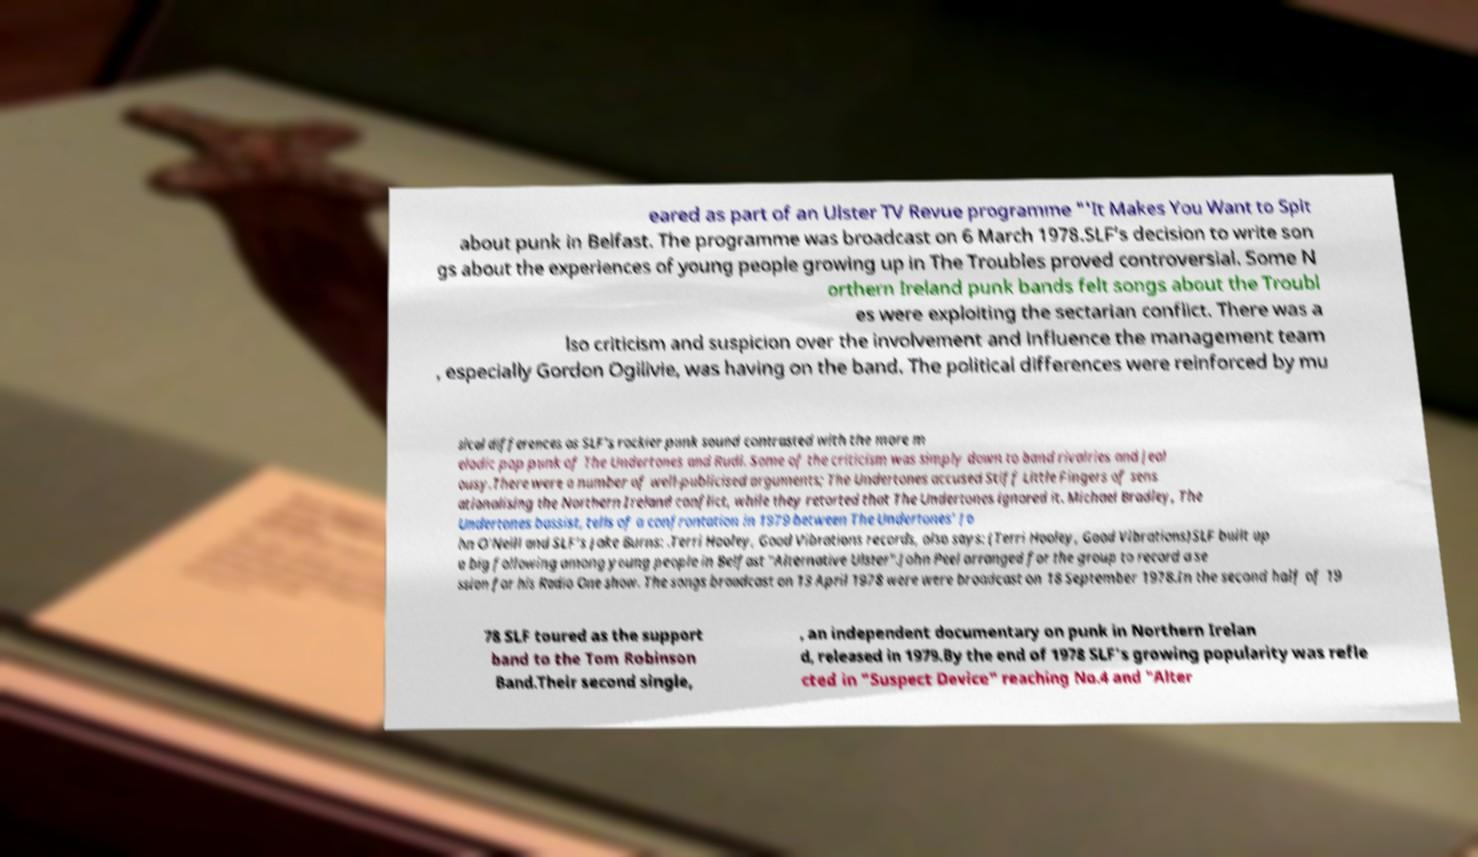Please identify and transcribe the text found in this image. eared as part of an Ulster TV Revue programme "'It Makes You Want to Spit about punk in Belfast. The programme was broadcast on 6 March 1978.SLF’s decision to write son gs about the experiences of young people growing up in The Troubles proved controversial. Some N orthern Ireland punk bands felt songs about the Troubl es were exploiting the sectarian conflict. There was a lso criticism and suspicion over the involvement and influence the management team , especially Gordon Ogilivie, was having on the band. The political differences were reinforced by mu sical differences as SLF’s rockier punk sound contrasted with the more m elodic pop punk of The Undertones and Rudi. Some of the criticism was simply down to band rivalries and jeal ousy.There were a number of well-publicised arguments; The Undertones accused Stiff Little Fingers of sens ationalising the Northern Ireland conflict, while they retorted that The Undertones ignored it. Michael Bradley, The Undertones bassist, tells of a confrontation in 1979 between The Undertones’ Jo hn O’Neill and SLF’s Jake Burns: .Terri Hooley, Good Vibrations records, also says: (Terri Hooley, Good Vibrations)SLF built up a big following among young people in Belfast "Alternative Ulster".John Peel arranged for the group to record a se ssion for his Radio One show. The songs broadcast on 13 April 1978 were were broadcast on 18 September 1978.In the second half of 19 78 SLF toured as the support band to the Tom Robinson Band.Their second single, , an independent documentary on punk in Northern Irelan d, released in 1979.By the end of 1978 SLF's growing popularity was refle cted in "Suspect Device" reaching No.4 and "Alter 